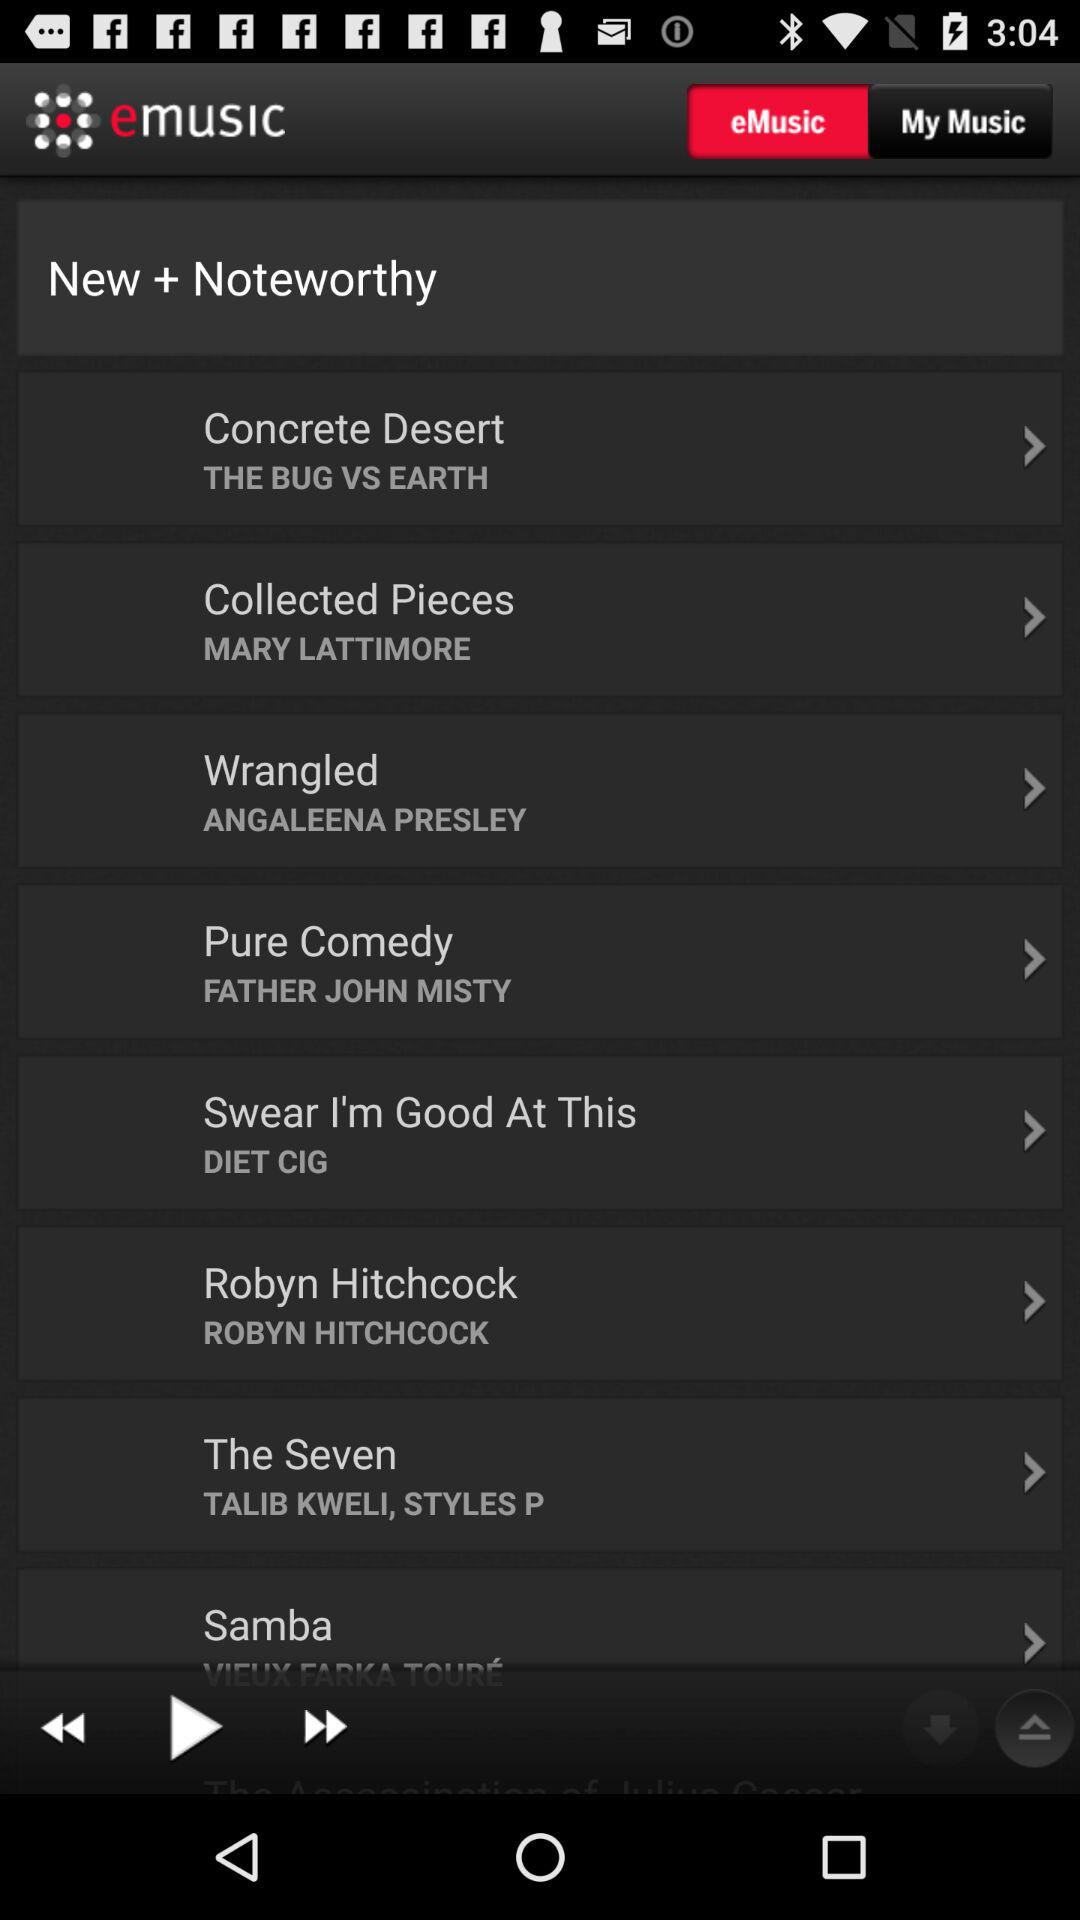What is the selected option? The selected option is "eMusic". 